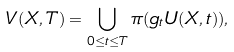<formula> <loc_0><loc_0><loc_500><loc_500>V ( X , T ) = \bigcup _ { 0 \leq t \leq T } \pi ( g _ { t } U ( X , t ) ) ,</formula> 